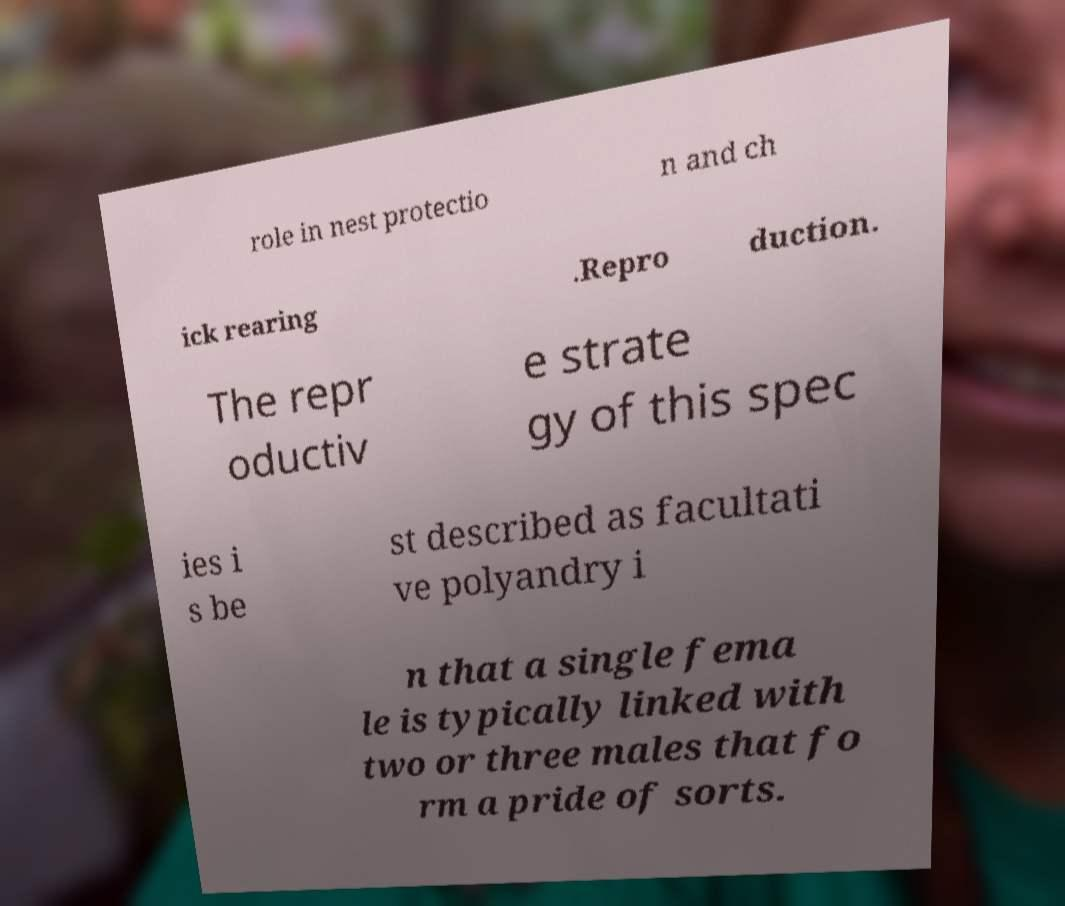Can you accurately transcribe the text from the provided image for me? role in nest protectio n and ch ick rearing .Repro duction. The repr oductiv e strate gy of this spec ies i s be st described as facultati ve polyandry i n that a single fema le is typically linked with two or three males that fo rm a pride of sorts. 